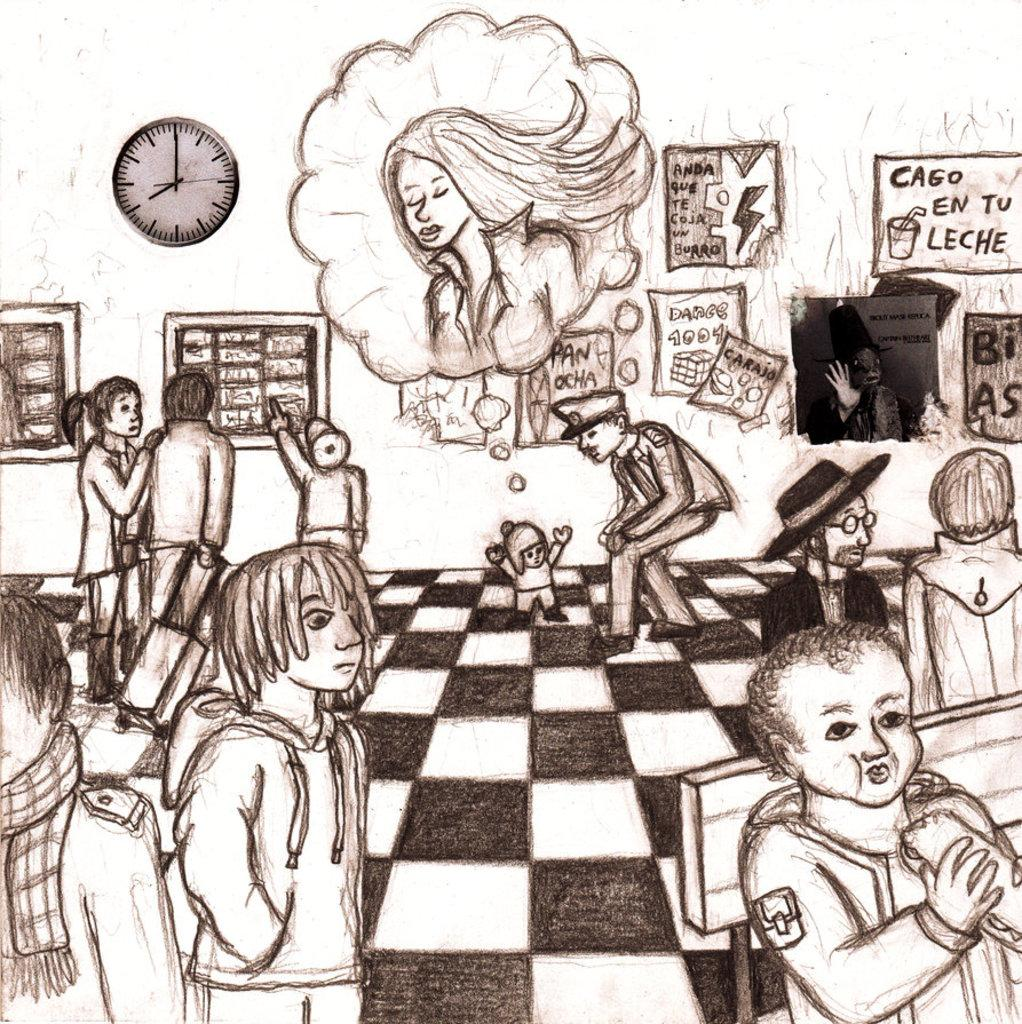Provide a one-sentence caption for the provided image. A pencil sketch of a police offer in a gallery talking to a small child and a sign in the background says Cago En Tu Leche. 